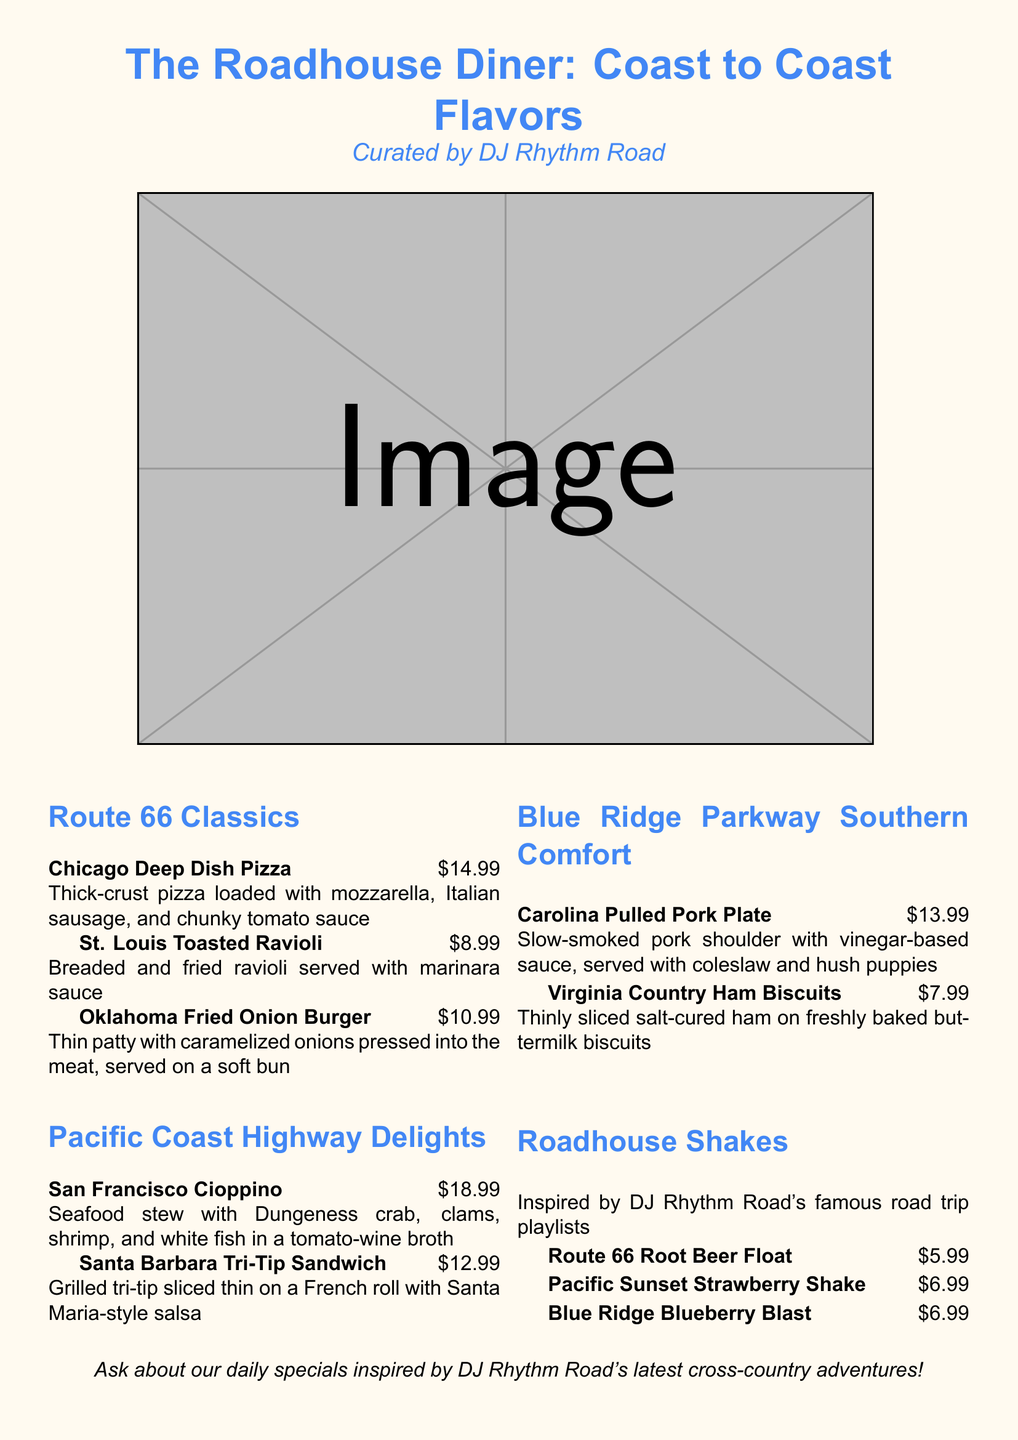what is the price of Chicago Deep Dish Pizza? The price of the Chicago Deep Dish Pizza is listed in the document.
Answer: $14.99 how many items are listed under Route 66 Classics? The document enumerates the number of items in this section.
Answer: 3 which sandwich is priced at $12.99? The document points out the price of each item along with their names.
Answer: Santa Barbara Tri-Tip Sandwich what type of dish is Carolina Pulled Pork Plate? The document specifies the type of dish for each menu item.
Answer: Plate which item has a reference to DJ Rhythm Road? The document indicates specific items that are inspired by DJ Rhythm Road.
Answer: Roadhouse Shakes which route has seafood as a highlight? The document categorizes dishes by their geographical origins and highlights the main ingredients.
Answer: Pacific Coast Highway what is the total number of shake options available? The document lists out the shake options provided under a specific section.
Answer: 3 what is the special feature of the Oklahoma Fried Onion Burger? The document describes unique qualities of dishes in their descriptions.
Answer: Caramelized onions 